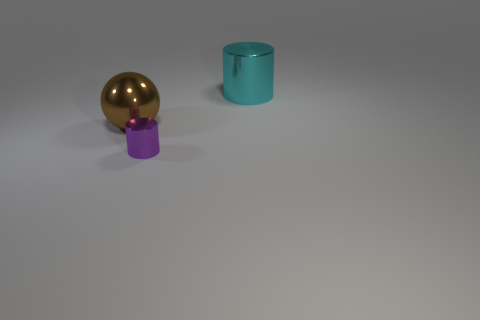Can you describe the size relationship between the objects? Certainly! In the image, there is a large golden sphere, which is the biggest object visible. To its right, there is a medium-sized cyan cylinder, and in front of it, there is a small purple cylinder. The size contrast creates an interesting dynamic within the composition. 